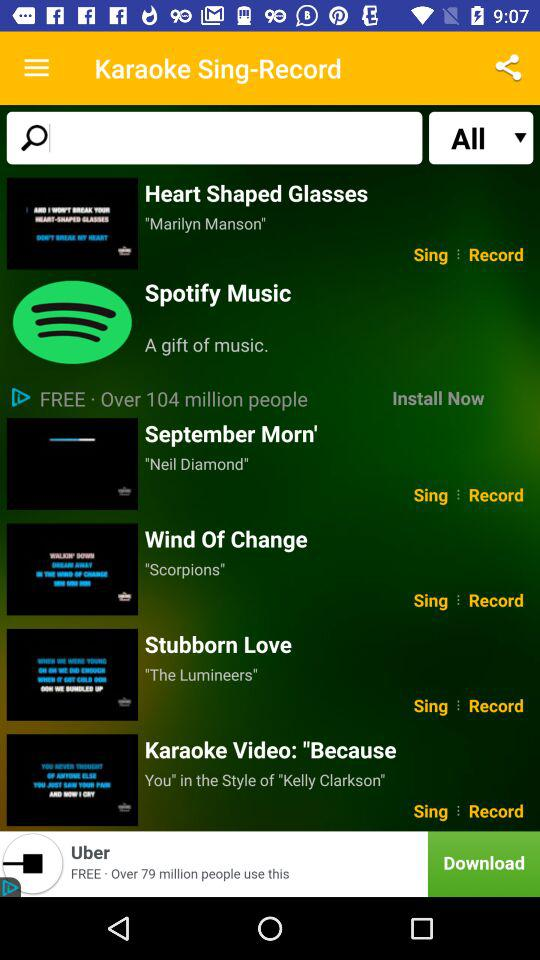What is the song's name sung by "Marilyn Manson"? The song's name is "Heart Shaped Glasses". 